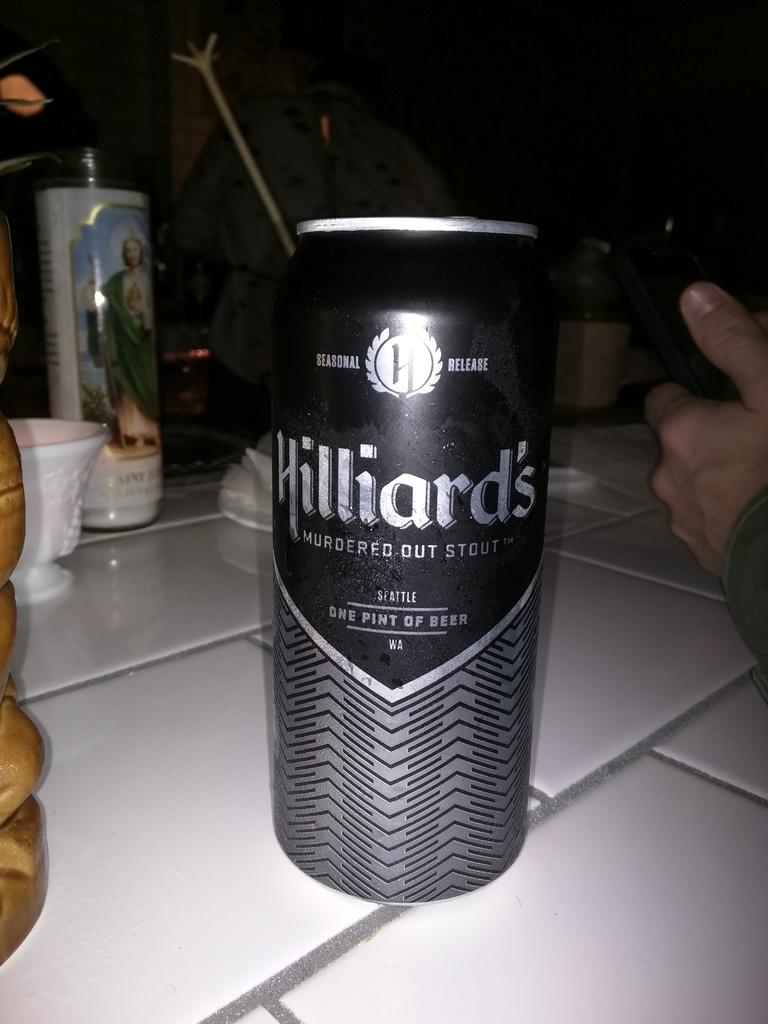<image>
Render a clear and concise summary of the photo. A person sitting at a table with a can of Hilliards Beer and a St. Jude devotion candle. 